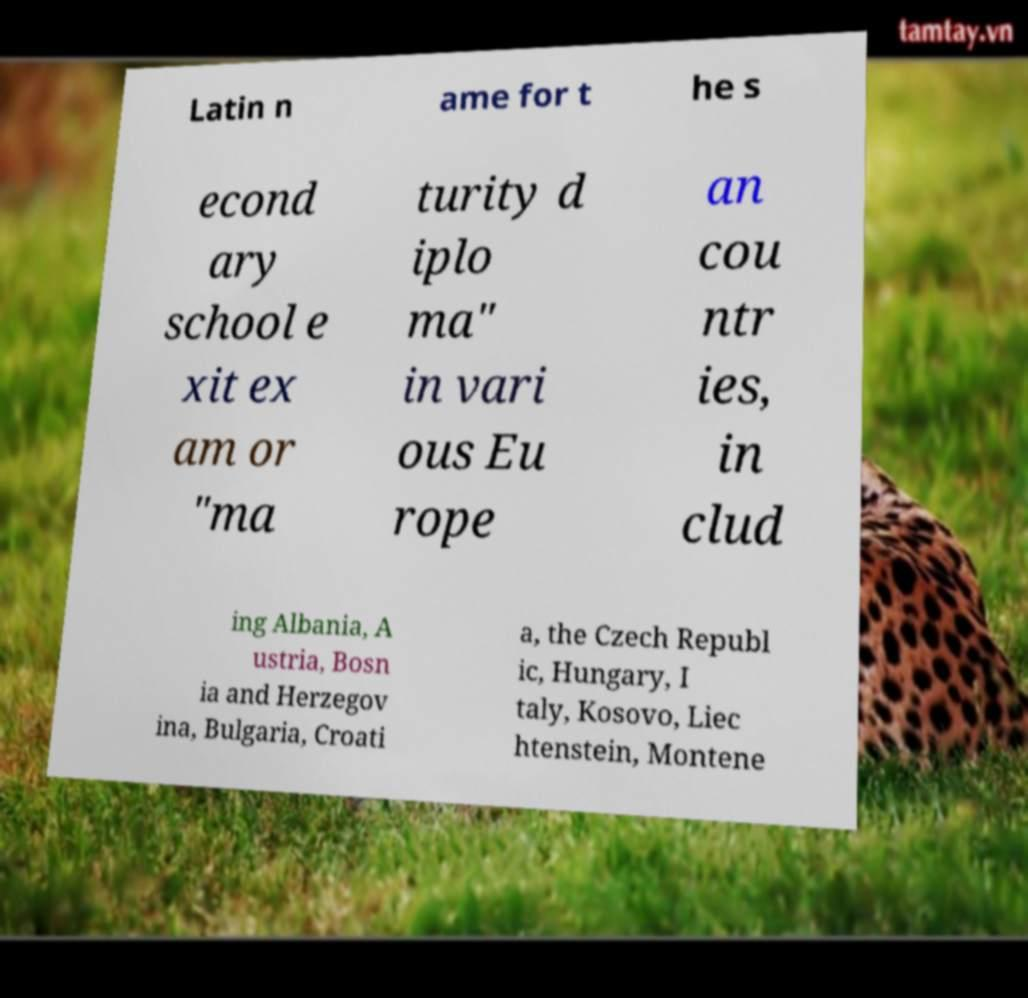Please read and relay the text visible in this image. What does it say? Latin n ame for t he s econd ary school e xit ex am or "ma turity d iplo ma" in vari ous Eu rope an cou ntr ies, in clud ing Albania, A ustria, Bosn ia and Herzegov ina, Bulgaria, Croati a, the Czech Republ ic, Hungary, I taly, Kosovo, Liec htenstein, Montene 